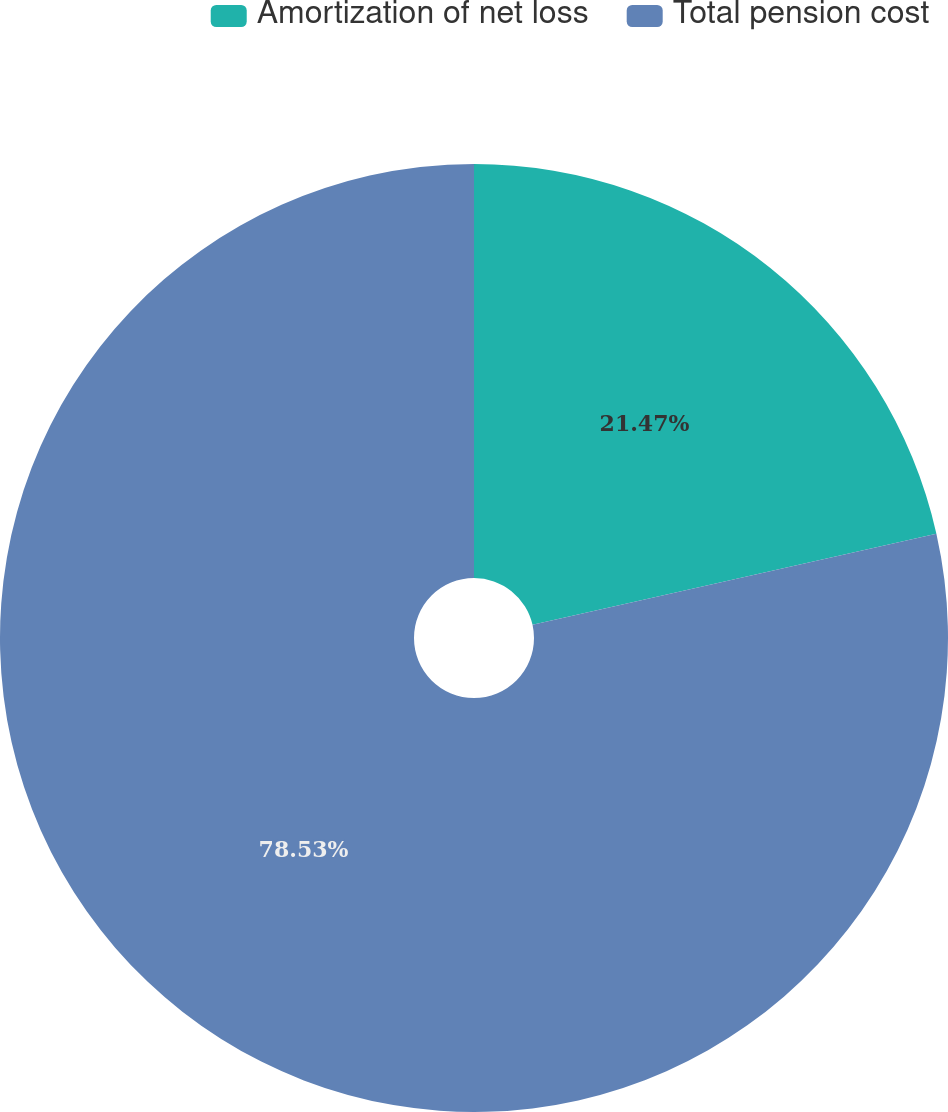Convert chart to OTSL. <chart><loc_0><loc_0><loc_500><loc_500><pie_chart><fcel>Amortization of net loss<fcel>Total pension cost<nl><fcel>21.47%<fcel>78.53%<nl></chart> 